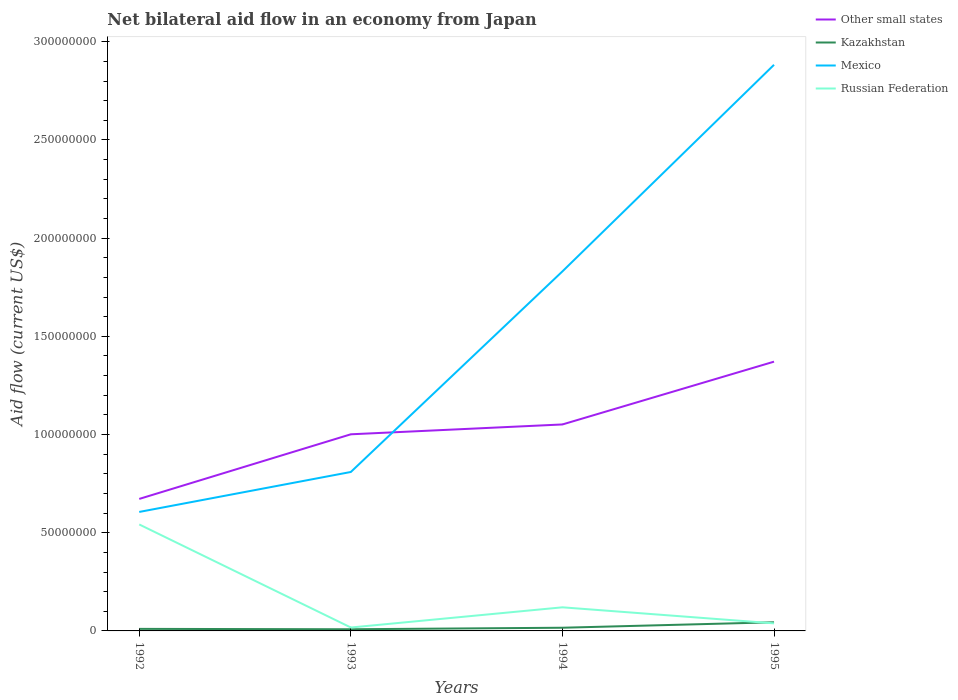Does the line corresponding to Mexico intersect with the line corresponding to Russian Federation?
Make the answer very short. No. Across all years, what is the maximum net bilateral aid flow in Other small states?
Provide a succinct answer. 6.72e+07. What is the total net bilateral aid flow in Mexico in the graph?
Make the answer very short. -2.28e+08. What is the difference between the highest and the second highest net bilateral aid flow in Russian Federation?
Give a very brief answer. 5.25e+07. Is the net bilateral aid flow in Kazakhstan strictly greater than the net bilateral aid flow in Other small states over the years?
Provide a succinct answer. Yes. How many lines are there?
Offer a terse response. 4. How many years are there in the graph?
Provide a short and direct response. 4. Are the values on the major ticks of Y-axis written in scientific E-notation?
Offer a very short reply. No. Where does the legend appear in the graph?
Give a very brief answer. Top right. How many legend labels are there?
Your answer should be very brief. 4. What is the title of the graph?
Give a very brief answer. Net bilateral aid flow in an economy from Japan. Does "Pakistan" appear as one of the legend labels in the graph?
Provide a short and direct response. No. What is the label or title of the X-axis?
Provide a short and direct response. Years. What is the label or title of the Y-axis?
Offer a terse response. Aid flow (current US$). What is the Aid flow (current US$) in Other small states in 1992?
Give a very brief answer. 6.72e+07. What is the Aid flow (current US$) of Kazakhstan in 1992?
Provide a short and direct response. 1.04e+06. What is the Aid flow (current US$) in Mexico in 1992?
Offer a terse response. 6.06e+07. What is the Aid flow (current US$) of Russian Federation in 1992?
Ensure brevity in your answer.  5.42e+07. What is the Aid flow (current US$) in Other small states in 1993?
Your response must be concise. 1.00e+08. What is the Aid flow (current US$) of Kazakhstan in 1993?
Give a very brief answer. 8.50e+05. What is the Aid flow (current US$) in Mexico in 1993?
Offer a terse response. 8.09e+07. What is the Aid flow (current US$) of Russian Federation in 1993?
Offer a very short reply. 1.74e+06. What is the Aid flow (current US$) of Other small states in 1994?
Make the answer very short. 1.05e+08. What is the Aid flow (current US$) in Kazakhstan in 1994?
Keep it short and to the point. 1.62e+06. What is the Aid flow (current US$) in Mexico in 1994?
Your answer should be compact. 1.83e+08. What is the Aid flow (current US$) in Russian Federation in 1994?
Your answer should be very brief. 1.20e+07. What is the Aid flow (current US$) of Other small states in 1995?
Ensure brevity in your answer.  1.37e+08. What is the Aid flow (current US$) of Kazakhstan in 1995?
Your response must be concise. 4.40e+06. What is the Aid flow (current US$) of Mexico in 1995?
Your answer should be very brief. 2.88e+08. What is the Aid flow (current US$) of Russian Federation in 1995?
Your response must be concise. 3.85e+06. Across all years, what is the maximum Aid flow (current US$) of Other small states?
Ensure brevity in your answer.  1.37e+08. Across all years, what is the maximum Aid flow (current US$) in Kazakhstan?
Your answer should be compact. 4.40e+06. Across all years, what is the maximum Aid flow (current US$) of Mexico?
Offer a very short reply. 2.88e+08. Across all years, what is the maximum Aid flow (current US$) of Russian Federation?
Ensure brevity in your answer.  5.42e+07. Across all years, what is the minimum Aid flow (current US$) in Other small states?
Ensure brevity in your answer.  6.72e+07. Across all years, what is the minimum Aid flow (current US$) in Kazakhstan?
Keep it short and to the point. 8.50e+05. Across all years, what is the minimum Aid flow (current US$) in Mexico?
Provide a succinct answer. 6.06e+07. Across all years, what is the minimum Aid flow (current US$) in Russian Federation?
Give a very brief answer. 1.74e+06. What is the total Aid flow (current US$) of Other small states in the graph?
Your response must be concise. 4.10e+08. What is the total Aid flow (current US$) in Kazakhstan in the graph?
Ensure brevity in your answer.  7.91e+06. What is the total Aid flow (current US$) in Mexico in the graph?
Keep it short and to the point. 6.13e+08. What is the total Aid flow (current US$) of Russian Federation in the graph?
Offer a very short reply. 7.18e+07. What is the difference between the Aid flow (current US$) of Other small states in 1992 and that in 1993?
Make the answer very short. -3.29e+07. What is the difference between the Aid flow (current US$) in Mexico in 1992 and that in 1993?
Give a very brief answer. -2.04e+07. What is the difference between the Aid flow (current US$) of Russian Federation in 1992 and that in 1993?
Make the answer very short. 5.25e+07. What is the difference between the Aid flow (current US$) of Other small states in 1992 and that in 1994?
Your answer should be very brief. -3.79e+07. What is the difference between the Aid flow (current US$) of Kazakhstan in 1992 and that in 1994?
Keep it short and to the point. -5.80e+05. What is the difference between the Aid flow (current US$) of Mexico in 1992 and that in 1994?
Make the answer very short. -1.22e+08. What is the difference between the Aid flow (current US$) of Russian Federation in 1992 and that in 1994?
Your response must be concise. 4.22e+07. What is the difference between the Aid flow (current US$) of Other small states in 1992 and that in 1995?
Your answer should be compact. -6.99e+07. What is the difference between the Aid flow (current US$) of Kazakhstan in 1992 and that in 1995?
Give a very brief answer. -3.36e+06. What is the difference between the Aid flow (current US$) in Mexico in 1992 and that in 1995?
Your answer should be very brief. -2.28e+08. What is the difference between the Aid flow (current US$) in Russian Federation in 1992 and that in 1995?
Give a very brief answer. 5.04e+07. What is the difference between the Aid flow (current US$) in Other small states in 1993 and that in 1994?
Offer a very short reply. -5.01e+06. What is the difference between the Aid flow (current US$) in Kazakhstan in 1993 and that in 1994?
Ensure brevity in your answer.  -7.70e+05. What is the difference between the Aid flow (current US$) in Mexico in 1993 and that in 1994?
Offer a very short reply. -1.02e+08. What is the difference between the Aid flow (current US$) of Russian Federation in 1993 and that in 1994?
Your response must be concise. -1.03e+07. What is the difference between the Aid flow (current US$) in Other small states in 1993 and that in 1995?
Your answer should be very brief. -3.70e+07. What is the difference between the Aid flow (current US$) of Kazakhstan in 1993 and that in 1995?
Ensure brevity in your answer.  -3.55e+06. What is the difference between the Aid flow (current US$) in Mexico in 1993 and that in 1995?
Provide a succinct answer. -2.07e+08. What is the difference between the Aid flow (current US$) of Russian Federation in 1993 and that in 1995?
Keep it short and to the point. -2.11e+06. What is the difference between the Aid flow (current US$) of Other small states in 1994 and that in 1995?
Your answer should be very brief. -3.20e+07. What is the difference between the Aid flow (current US$) in Kazakhstan in 1994 and that in 1995?
Make the answer very short. -2.78e+06. What is the difference between the Aid flow (current US$) in Mexico in 1994 and that in 1995?
Give a very brief answer. -1.05e+08. What is the difference between the Aid flow (current US$) in Russian Federation in 1994 and that in 1995?
Make the answer very short. 8.17e+06. What is the difference between the Aid flow (current US$) in Other small states in 1992 and the Aid flow (current US$) in Kazakhstan in 1993?
Ensure brevity in your answer.  6.64e+07. What is the difference between the Aid flow (current US$) in Other small states in 1992 and the Aid flow (current US$) in Mexico in 1993?
Keep it short and to the point. -1.37e+07. What is the difference between the Aid flow (current US$) of Other small states in 1992 and the Aid flow (current US$) of Russian Federation in 1993?
Offer a terse response. 6.55e+07. What is the difference between the Aid flow (current US$) in Kazakhstan in 1992 and the Aid flow (current US$) in Mexico in 1993?
Make the answer very short. -7.99e+07. What is the difference between the Aid flow (current US$) in Kazakhstan in 1992 and the Aid flow (current US$) in Russian Federation in 1993?
Offer a very short reply. -7.00e+05. What is the difference between the Aid flow (current US$) in Mexico in 1992 and the Aid flow (current US$) in Russian Federation in 1993?
Provide a succinct answer. 5.88e+07. What is the difference between the Aid flow (current US$) in Other small states in 1992 and the Aid flow (current US$) in Kazakhstan in 1994?
Offer a terse response. 6.56e+07. What is the difference between the Aid flow (current US$) of Other small states in 1992 and the Aid flow (current US$) of Mexico in 1994?
Your answer should be very brief. -1.16e+08. What is the difference between the Aid flow (current US$) of Other small states in 1992 and the Aid flow (current US$) of Russian Federation in 1994?
Offer a very short reply. 5.52e+07. What is the difference between the Aid flow (current US$) in Kazakhstan in 1992 and the Aid flow (current US$) in Mexico in 1994?
Provide a short and direct response. -1.82e+08. What is the difference between the Aid flow (current US$) in Kazakhstan in 1992 and the Aid flow (current US$) in Russian Federation in 1994?
Your answer should be compact. -1.10e+07. What is the difference between the Aid flow (current US$) of Mexico in 1992 and the Aid flow (current US$) of Russian Federation in 1994?
Ensure brevity in your answer.  4.86e+07. What is the difference between the Aid flow (current US$) in Other small states in 1992 and the Aid flow (current US$) in Kazakhstan in 1995?
Provide a succinct answer. 6.28e+07. What is the difference between the Aid flow (current US$) of Other small states in 1992 and the Aid flow (current US$) of Mexico in 1995?
Make the answer very short. -2.21e+08. What is the difference between the Aid flow (current US$) in Other small states in 1992 and the Aid flow (current US$) in Russian Federation in 1995?
Your response must be concise. 6.34e+07. What is the difference between the Aid flow (current US$) in Kazakhstan in 1992 and the Aid flow (current US$) in Mexico in 1995?
Ensure brevity in your answer.  -2.87e+08. What is the difference between the Aid flow (current US$) of Kazakhstan in 1992 and the Aid flow (current US$) of Russian Federation in 1995?
Make the answer very short. -2.81e+06. What is the difference between the Aid flow (current US$) of Mexico in 1992 and the Aid flow (current US$) of Russian Federation in 1995?
Provide a succinct answer. 5.67e+07. What is the difference between the Aid flow (current US$) of Other small states in 1993 and the Aid flow (current US$) of Kazakhstan in 1994?
Provide a succinct answer. 9.85e+07. What is the difference between the Aid flow (current US$) in Other small states in 1993 and the Aid flow (current US$) in Mexico in 1994?
Your answer should be compact. -8.30e+07. What is the difference between the Aid flow (current US$) of Other small states in 1993 and the Aid flow (current US$) of Russian Federation in 1994?
Keep it short and to the point. 8.81e+07. What is the difference between the Aid flow (current US$) in Kazakhstan in 1993 and the Aid flow (current US$) in Mexico in 1994?
Your answer should be compact. -1.82e+08. What is the difference between the Aid flow (current US$) of Kazakhstan in 1993 and the Aid flow (current US$) of Russian Federation in 1994?
Your response must be concise. -1.12e+07. What is the difference between the Aid flow (current US$) of Mexico in 1993 and the Aid flow (current US$) of Russian Federation in 1994?
Your response must be concise. 6.89e+07. What is the difference between the Aid flow (current US$) in Other small states in 1993 and the Aid flow (current US$) in Kazakhstan in 1995?
Your response must be concise. 9.57e+07. What is the difference between the Aid flow (current US$) of Other small states in 1993 and the Aid flow (current US$) of Mexico in 1995?
Provide a short and direct response. -1.88e+08. What is the difference between the Aid flow (current US$) in Other small states in 1993 and the Aid flow (current US$) in Russian Federation in 1995?
Provide a succinct answer. 9.63e+07. What is the difference between the Aid flow (current US$) of Kazakhstan in 1993 and the Aid flow (current US$) of Mexico in 1995?
Provide a short and direct response. -2.87e+08. What is the difference between the Aid flow (current US$) in Kazakhstan in 1993 and the Aid flow (current US$) in Russian Federation in 1995?
Your answer should be compact. -3.00e+06. What is the difference between the Aid flow (current US$) in Mexico in 1993 and the Aid flow (current US$) in Russian Federation in 1995?
Provide a short and direct response. 7.71e+07. What is the difference between the Aid flow (current US$) of Other small states in 1994 and the Aid flow (current US$) of Kazakhstan in 1995?
Offer a very short reply. 1.01e+08. What is the difference between the Aid flow (current US$) of Other small states in 1994 and the Aid flow (current US$) of Mexico in 1995?
Your answer should be very brief. -1.83e+08. What is the difference between the Aid flow (current US$) of Other small states in 1994 and the Aid flow (current US$) of Russian Federation in 1995?
Your response must be concise. 1.01e+08. What is the difference between the Aid flow (current US$) of Kazakhstan in 1994 and the Aid flow (current US$) of Mexico in 1995?
Your response must be concise. -2.87e+08. What is the difference between the Aid flow (current US$) in Kazakhstan in 1994 and the Aid flow (current US$) in Russian Federation in 1995?
Keep it short and to the point. -2.23e+06. What is the difference between the Aid flow (current US$) of Mexico in 1994 and the Aid flow (current US$) of Russian Federation in 1995?
Your answer should be compact. 1.79e+08. What is the average Aid flow (current US$) in Other small states per year?
Give a very brief answer. 1.02e+08. What is the average Aid flow (current US$) in Kazakhstan per year?
Provide a short and direct response. 1.98e+06. What is the average Aid flow (current US$) of Mexico per year?
Provide a succinct answer. 1.53e+08. What is the average Aid flow (current US$) of Russian Federation per year?
Your answer should be very brief. 1.80e+07. In the year 1992, what is the difference between the Aid flow (current US$) of Other small states and Aid flow (current US$) of Kazakhstan?
Make the answer very short. 6.62e+07. In the year 1992, what is the difference between the Aid flow (current US$) of Other small states and Aid flow (current US$) of Mexico?
Keep it short and to the point. 6.63e+06. In the year 1992, what is the difference between the Aid flow (current US$) in Other small states and Aid flow (current US$) in Russian Federation?
Keep it short and to the point. 1.30e+07. In the year 1992, what is the difference between the Aid flow (current US$) of Kazakhstan and Aid flow (current US$) of Mexico?
Offer a very short reply. -5.96e+07. In the year 1992, what is the difference between the Aid flow (current US$) of Kazakhstan and Aid flow (current US$) of Russian Federation?
Give a very brief answer. -5.32e+07. In the year 1992, what is the difference between the Aid flow (current US$) in Mexico and Aid flow (current US$) in Russian Federation?
Offer a terse response. 6.37e+06. In the year 1993, what is the difference between the Aid flow (current US$) in Other small states and Aid flow (current US$) in Kazakhstan?
Ensure brevity in your answer.  9.93e+07. In the year 1993, what is the difference between the Aid flow (current US$) in Other small states and Aid flow (current US$) in Mexico?
Offer a very short reply. 1.92e+07. In the year 1993, what is the difference between the Aid flow (current US$) in Other small states and Aid flow (current US$) in Russian Federation?
Make the answer very short. 9.84e+07. In the year 1993, what is the difference between the Aid flow (current US$) of Kazakhstan and Aid flow (current US$) of Mexico?
Keep it short and to the point. -8.01e+07. In the year 1993, what is the difference between the Aid flow (current US$) in Kazakhstan and Aid flow (current US$) in Russian Federation?
Your response must be concise. -8.90e+05. In the year 1993, what is the difference between the Aid flow (current US$) in Mexico and Aid flow (current US$) in Russian Federation?
Provide a succinct answer. 7.92e+07. In the year 1994, what is the difference between the Aid flow (current US$) in Other small states and Aid flow (current US$) in Kazakhstan?
Offer a very short reply. 1.04e+08. In the year 1994, what is the difference between the Aid flow (current US$) of Other small states and Aid flow (current US$) of Mexico?
Your answer should be very brief. -7.80e+07. In the year 1994, what is the difference between the Aid flow (current US$) in Other small states and Aid flow (current US$) in Russian Federation?
Your answer should be compact. 9.31e+07. In the year 1994, what is the difference between the Aid flow (current US$) of Kazakhstan and Aid flow (current US$) of Mexico?
Make the answer very short. -1.81e+08. In the year 1994, what is the difference between the Aid flow (current US$) in Kazakhstan and Aid flow (current US$) in Russian Federation?
Ensure brevity in your answer.  -1.04e+07. In the year 1994, what is the difference between the Aid flow (current US$) in Mexico and Aid flow (current US$) in Russian Federation?
Provide a succinct answer. 1.71e+08. In the year 1995, what is the difference between the Aid flow (current US$) in Other small states and Aid flow (current US$) in Kazakhstan?
Offer a terse response. 1.33e+08. In the year 1995, what is the difference between the Aid flow (current US$) of Other small states and Aid flow (current US$) of Mexico?
Your response must be concise. -1.51e+08. In the year 1995, what is the difference between the Aid flow (current US$) in Other small states and Aid flow (current US$) in Russian Federation?
Ensure brevity in your answer.  1.33e+08. In the year 1995, what is the difference between the Aid flow (current US$) of Kazakhstan and Aid flow (current US$) of Mexico?
Give a very brief answer. -2.84e+08. In the year 1995, what is the difference between the Aid flow (current US$) of Mexico and Aid flow (current US$) of Russian Federation?
Give a very brief answer. 2.84e+08. What is the ratio of the Aid flow (current US$) in Other small states in 1992 to that in 1993?
Give a very brief answer. 0.67. What is the ratio of the Aid flow (current US$) in Kazakhstan in 1992 to that in 1993?
Offer a terse response. 1.22. What is the ratio of the Aid flow (current US$) in Mexico in 1992 to that in 1993?
Your answer should be very brief. 0.75. What is the ratio of the Aid flow (current US$) of Russian Federation in 1992 to that in 1993?
Your response must be concise. 31.16. What is the ratio of the Aid flow (current US$) of Other small states in 1992 to that in 1994?
Offer a terse response. 0.64. What is the ratio of the Aid flow (current US$) in Kazakhstan in 1992 to that in 1994?
Provide a short and direct response. 0.64. What is the ratio of the Aid flow (current US$) in Mexico in 1992 to that in 1994?
Offer a terse response. 0.33. What is the ratio of the Aid flow (current US$) of Russian Federation in 1992 to that in 1994?
Keep it short and to the point. 4.51. What is the ratio of the Aid flow (current US$) of Other small states in 1992 to that in 1995?
Offer a very short reply. 0.49. What is the ratio of the Aid flow (current US$) in Kazakhstan in 1992 to that in 1995?
Make the answer very short. 0.24. What is the ratio of the Aid flow (current US$) in Mexico in 1992 to that in 1995?
Your answer should be compact. 0.21. What is the ratio of the Aid flow (current US$) in Russian Federation in 1992 to that in 1995?
Offer a terse response. 14.08. What is the ratio of the Aid flow (current US$) in Other small states in 1993 to that in 1994?
Provide a succinct answer. 0.95. What is the ratio of the Aid flow (current US$) of Kazakhstan in 1993 to that in 1994?
Ensure brevity in your answer.  0.52. What is the ratio of the Aid flow (current US$) of Mexico in 1993 to that in 1994?
Provide a succinct answer. 0.44. What is the ratio of the Aid flow (current US$) of Russian Federation in 1993 to that in 1994?
Make the answer very short. 0.14. What is the ratio of the Aid flow (current US$) of Other small states in 1993 to that in 1995?
Provide a short and direct response. 0.73. What is the ratio of the Aid flow (current US$) in Kazakhstan in 1993 to that in 1995?
Your answer should be compact. 0.19. What is the ratio of the Aid flow (current US$) of Mexico in 1993 to that in 1995?
Offer a terse response. 0.28. What is the ratio of the Aid flow (current US$) of Russian Federation in 1993 to that in 1995?
Your answer should be compact. 0.45. What is the ratio of the Aid flow (current US$) of Other small states in 1994 to that in 1995?
Keep it short and to the point. 0.77. What is the ratio of the Aid flow (current US$) in Kazakhstan in 1994 to that in 1995?
Give a very brief answer. 0.37. What is the ratio of the Aid flow (current US$) of Mexico in 1994 to that in 1995?
Give a very brief answer. 0.64. What is the ratio of the Aid flow (current US$) in Russian Federation in 1994 to that in 1995?
Offer a terse response. 3.12. What is the difference between the highest and the second highest Aid flow (current US$) in Other small states?
Your answer should be very brief. 3.20e+07. What is the difference between the highest and the second highest Aid flow (current US$) of Kazakhstan?
Give a very brief answer. 2.78e+06. What is the difference between the highest and the second highest Aid flow (current US$) of Mexico?
Ensure brevity in your answer.  1.05e+08. What is the difference between the highest and the second highest Aid flow (current US$) of Russian Federation?
Offer a terse response. 4.22e+07. What is the difference between the highest and the lowest Aid flow (current US$) in Other small states?
Your answer should be compact. 6.99e+07. What is the difference between the highest and the lowest Aid flow (current US$) of Kazakhstan?
Provide a short and direct response. 3.55e+06. What is the difference between the highest and the lowest Aid flow (current US$) of Mexico?
Make the answer very short. 2.28e+08. What is the difference between the highest and the lowest Aid flow (current US$) of Russian Federation?
Your response must be concise. 5.25e+07. 